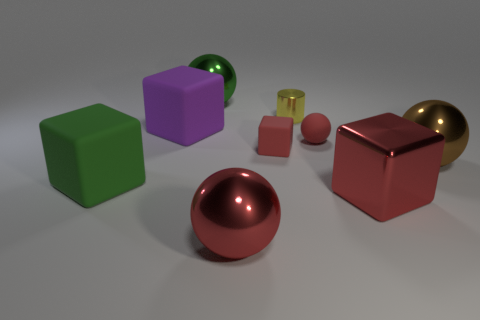Can you describe the overall arrangement and composition of the objects in this image? Certainly! The image presents an interesting assortment of geometric shapes carefully arranged on a neutral surface. In the foreground, a lustrous, copper sphere catches the eye, while a collection of matte blocks in green, purple, and two shades of red forms a loose semi-circle around the central metallic objects. The background is softly lit, casting gentle shadows and highlighting the textures and colors of each item. 